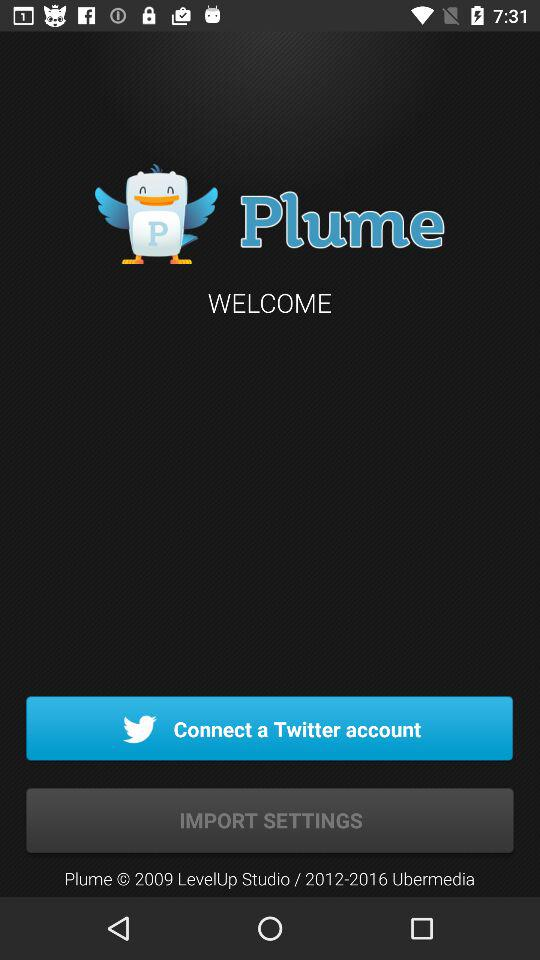What is the name of the application? The name of the application is "Plume". 